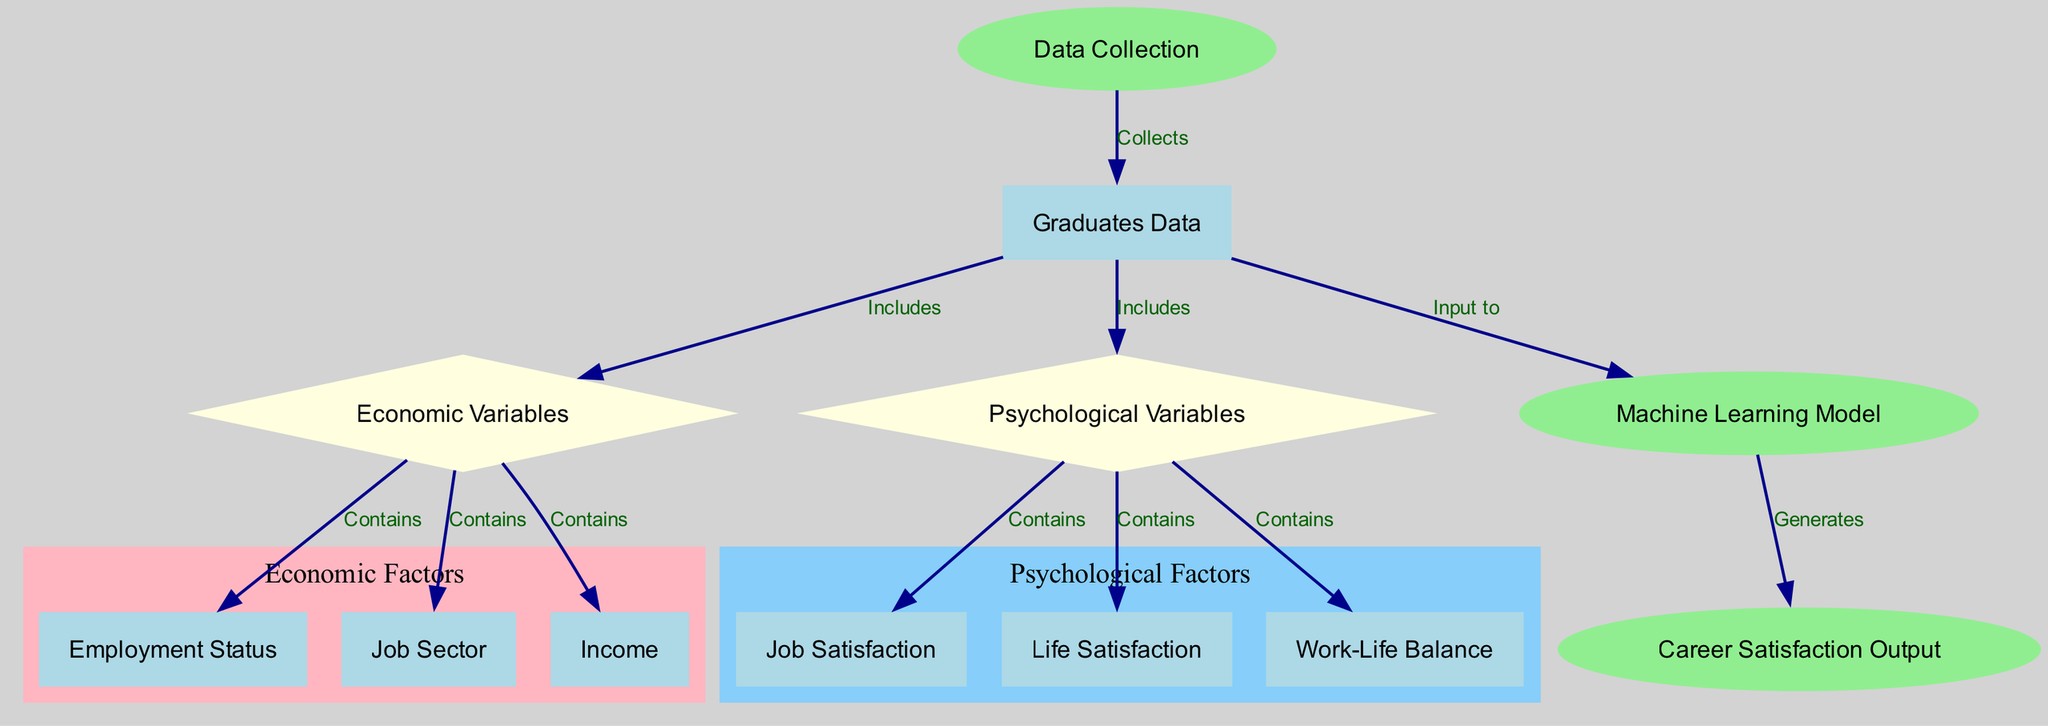What is the starting point of the diagram? The starting point is the "Data Collection" node, which indicates where the process begins in gathering information.
Answer: Data Collection How many nodes are present in the diagram? There are 11 nodes listed in the data structure, each representing different components of the career satisfaction model.
Answer: 11 What type of node is "job satisfaction"? "Job satisfaction" is classified as a node within the "Psychological Variables" category, which is represented as a diamond shape in the diagram.
Answer: Diamond What does the "Machine Learning Model" generate? The "Machine Learning Model" produces the output of "Career Satisfaction Output", indicating the end result of the data processing.
Answer: Career Satisfaction Output What relationship exists between "Graduates Data" and "Economic Variables"? "Graduates Data" includes "Economic Variables," showing that economic factors are a subset of the information gathered about graduates.
Answer: Includes Which two variables are identified as psychological variables in the diagram? The psychological variables identified are "Job Satisfaction" and "Life Satisfaction," both of which are essential components of the broader category.
Answer: Job Satisfaction, Life Satisfaction Which subgraph is represented in pink? The pink subgraph represents "Economic Factors," as indicated by the color coding and grouping of relevant nodes associated with economic variables.
Answer: Economic Factors How many edges connect the nodes to the "Machine Learning Model"? Three edges connect to the "Machine Learning Model," incoming from "Graduates Data," indicating that it uses input from this source.
Answer: 3 Which node contains information about "Income"? The "Income" information is contained within the "Economic Variables" node, which focuses on financial aspects related to career satisfaction.
Answer: Economic Variables 